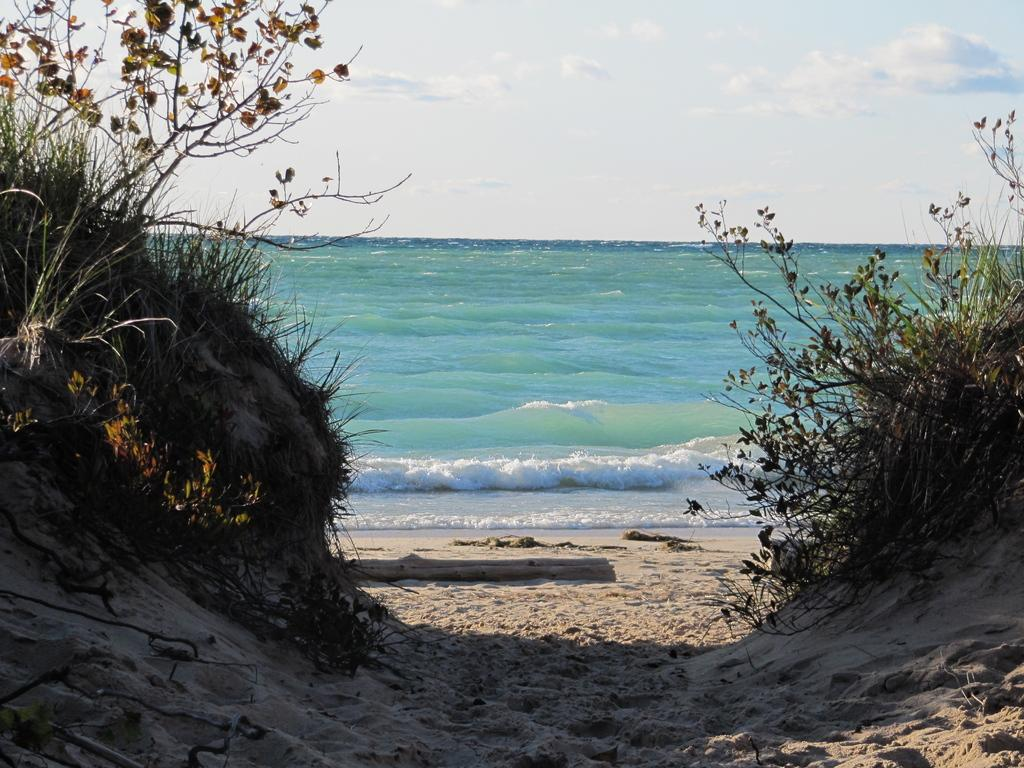What celestial bodies can be seen in the image? There are planets visible in the image. What natural element is present in the image? There is water visible in the image. What is visible in the background of the image? The sky is visible in the background of the image. What is the purpose of the aunt's stocking in the image? There is no aunt or stocking present in the image; it features planets and water. 